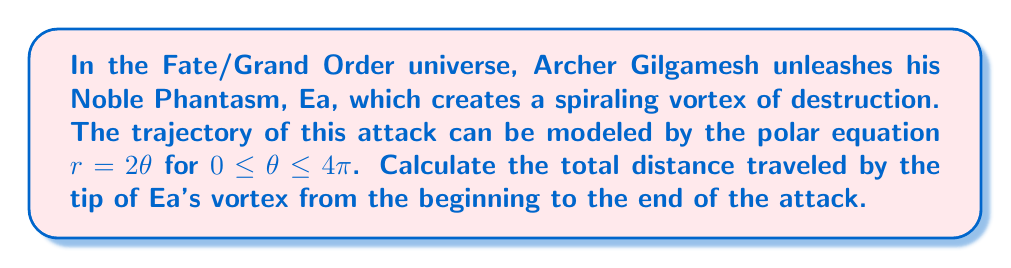Can you answer this question? To solve this problem, we need to calculate the arc length of the spiral described by the polar equation $r = 2\theta$ from $\theta = 0$ to $\theta = 4\pi$. Let's break it down step-by-step:

1) The formula for arc length in polar coordinates is:

   $$L = \int_a^b \sqrt{r^2 + \left(\frac{dr}{d\theta}\right)^2} d\theta$$

2) For our equation $r = 2\theta$, we need to find $\frac{dr}{d\theta}$:
   
   $$\frac{dr}{d\theta} = 2$$

3) Now, let's substitute these into our arc length formula:

   $$L = \int_0^{4\pi} \sqrt{(2\theta)^2 + 2^2} d\theta$$

4) Simplify inside the square root:

   $$L = \int_0^{4\pi} \sqrt{4\theta^2 + 4} d\theta$$

5) Factor out the 4:

   $$L = 2\int_0^{4\pi} \sqrt{\theta^2 + 1} d\theta$$

6) This integral doesn't have an elementary antiderivative. We need to use the hyperbolic functions. The antiderivative is:

   $$\frac{1}{2}[\theta\sqrt{\theta^2+1} + \ln(\theta + \sqrt{\theta^2+1})]$$

7) Now, we can apply the limits:

   $$L = \left.\frac{1}{2}[\theta\sqrt{\theta^2+1} + \ln(\theta + \sqrt{\theta^2+1})]\right|_0^{4\pi}$$

8) Evaluate at $\theta = 4\pi$:

   $$\frac{1}{2}[4\pi\sqrt{16\pi^2+1} + \ln(4\pi + \sqrt{16\pi^2+1})]$$

9) Evaluate at $\theta = 0$:

   $$\frac{1}{2}[0 + \ln(0 + 1)] = 0$$

10) Subtract the lower limit from the upper limit:

    $$L = \frac{1}{2}[4\pi\sqrt{16\pi^2+1} + \ln(4\pi + \sqrt{16\pi^2+1})]$$

This is the exact answer. For a numerical approximation, we can use a calculator to get $L \approx 159.43$.
Answer: The total distance traveled by the tip of Ea's vortex is 
$$\frac{1}{2}[4\pi\sqrt{16\pi^2+1} + \ln(4\pi + \sqrt{16\pi^2+1})]$$
which is approximately 159.43 units. 